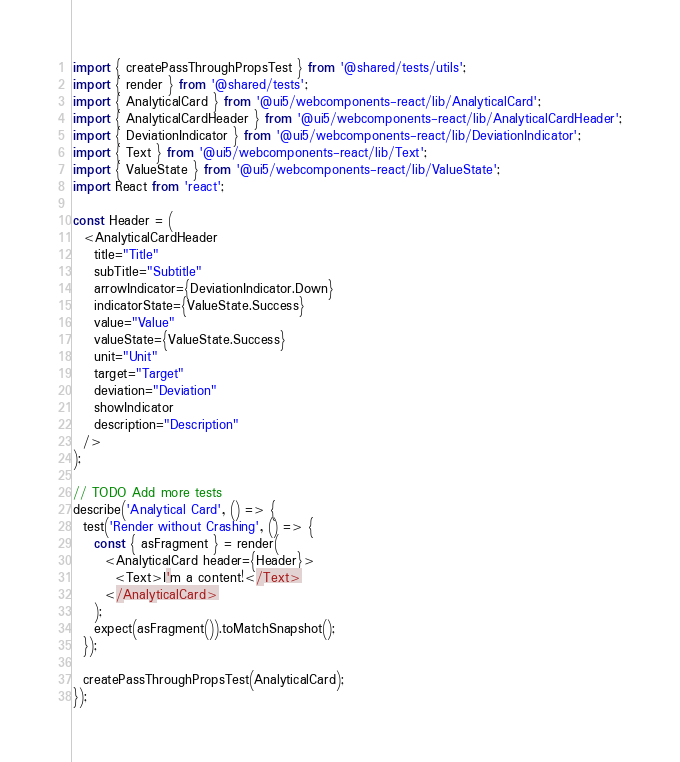<code> <loc_0><loc_0><loc_500><loc_500><_TypeScript_>import { createPassThroughPropsTest } from '@shared/tests/utils';
import { render } from '@shared/tests';
import { AnalyticalCard } from '@ui5/webcomponents-react/lib/AnalyticalCard';
import { AnalyticalCardHeader } from '@ui5/webcomponents-react/lib/AnalyticalCardHeader';
import { DeviationIndicator } from '@ui5/webcomponents-react/lib/DeviationIndicator';
import { Text } from '@ui5/webcomponents-react/lib/Text';
import { ValueState } from '@ui5/webcomponents-react/lib/ValueState';
import React from 'react';

const Header = (
  <AnalyticalCardHeader
    title="Title"
    subTitle="Subtitle"
    arrowIndicator={DeviationIndicator.Down}
    indicatorState={ValueState.Success}
    value="Value"
    valueState={ValueState.Success}
    unit="Unit"
    target="Target"
    deviation="Deviation"
    showIndicator
    description="Description"
  />
);

// TODO Add more tests
describe('Analytical Card', () => {
  test('Render without Crashing', () => {
    const { asFragment } = render(
      <AnalyticalCard header={Header}>
        <Text>I'm a content!</Text>
      </AnalyticalCard>
    );
    expect(asFragment()).toMatchSnapshot();
  });

  createPassThroughPropsTest(AnalyticalCard);
});
</code> 